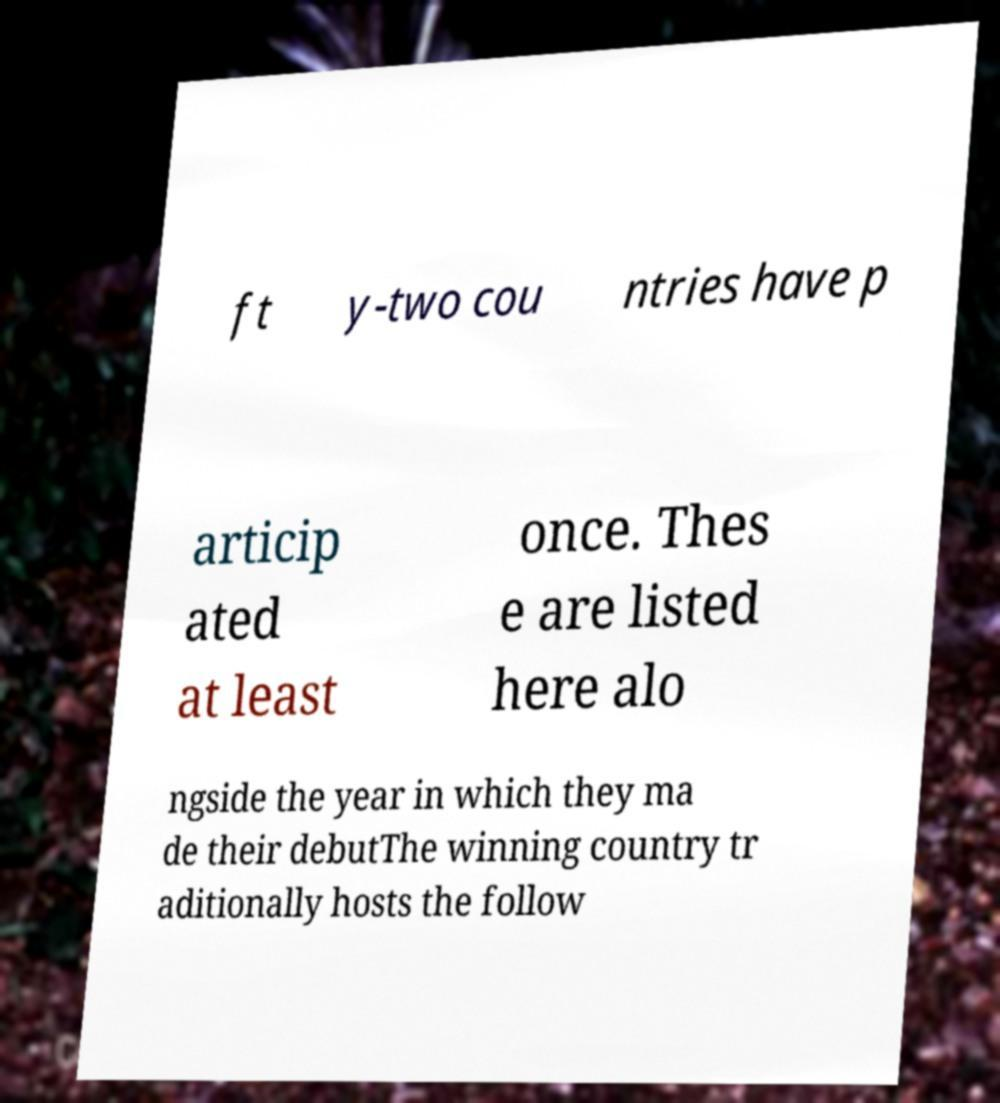I need the written content from this picture converted into text. Can you do that? ft y-two cou ntries have p articip ated at least once. Thes e are listed here alo ngside the year in which they ma de their debutThe winning country tr aditionally hosts the follow 